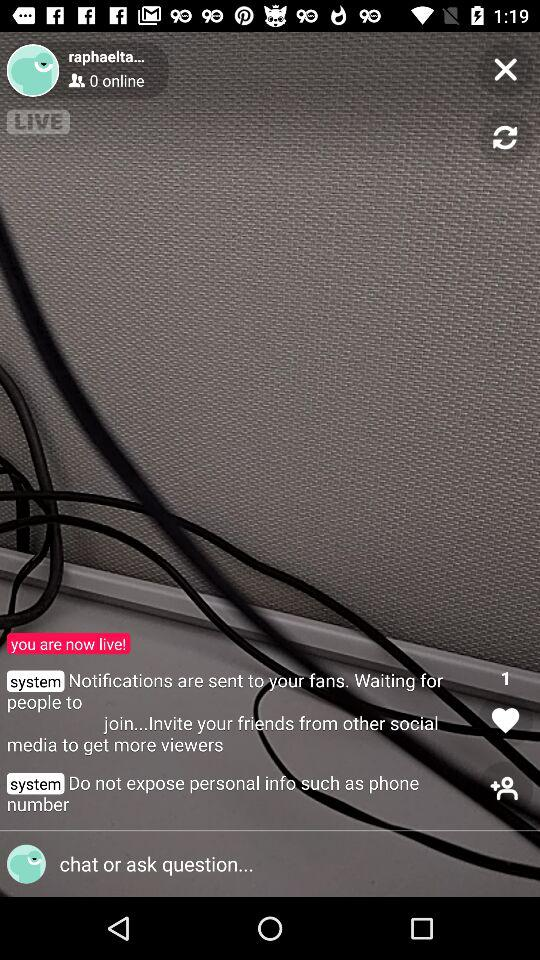How many people are online? 0 